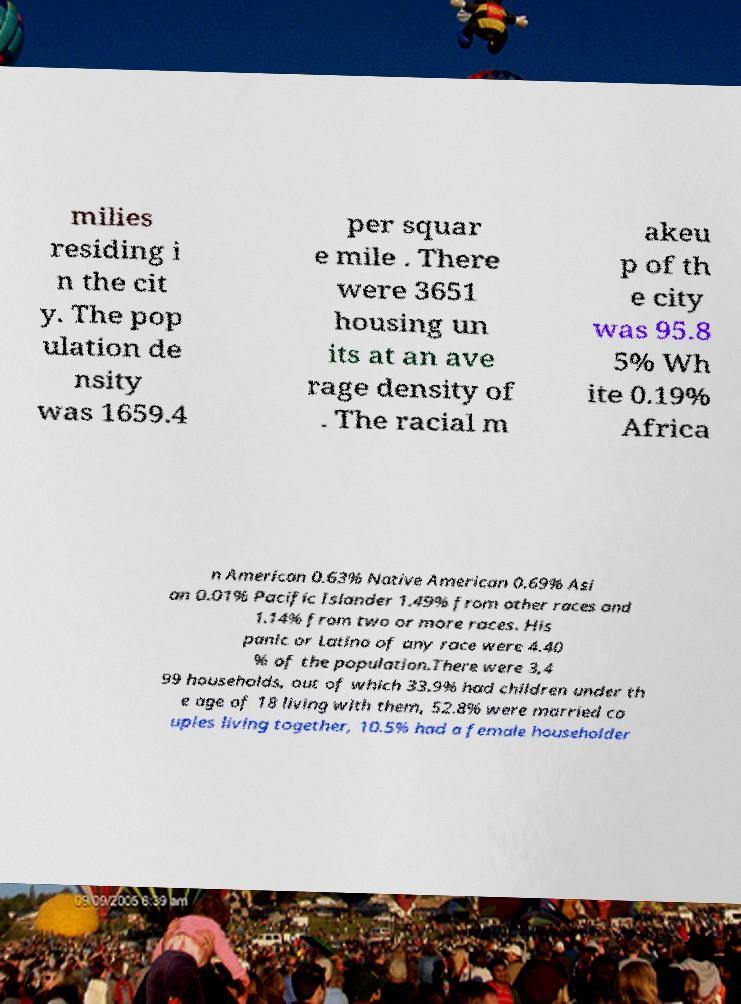For documentation purposes, I need the text within this image transcribed. Could you provide that? milies residing i n the cit y. The pop ulation de nsity was 1659.4 per squar e mile . There were 3651 housing un its at an ave rage density of . The racial m akeu p of th e city was 95.8 5% Wh ite 0.19% Africa n American 0.63% Native American 0.69% Asi an 0.01% Pacific Islander 1.49% from other races and 1.14% from two or more races. His panic or Latino of any race were 4.40 % of the population.There were 3,4 99 households, out of which 33.9% had children under th e age of 18 living with them, 52.8% were married co uples living together, 10.5% had a female householder 